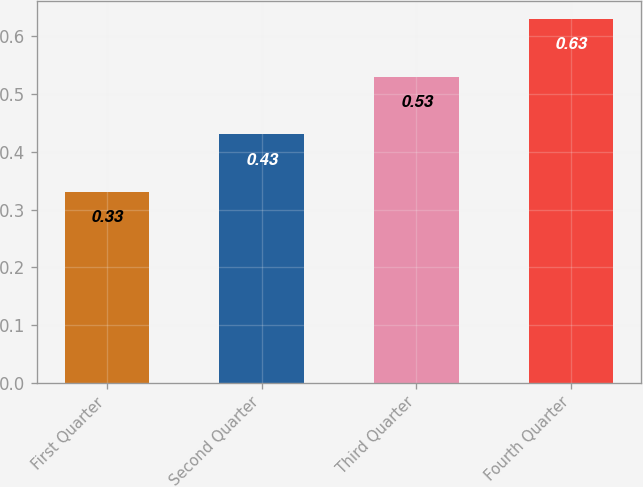Convert chart. <chart><loc_0><loc_0><loc_500><loc_500><bar_chart><fcel>First Quarter<fcel>Second Quarter<fcel>Third Quarter<fcel>Fourth Quarter<nl><fcel>0.33<fcel>0.43<fcel>0.53<fcel>0.63<nl></chart> 